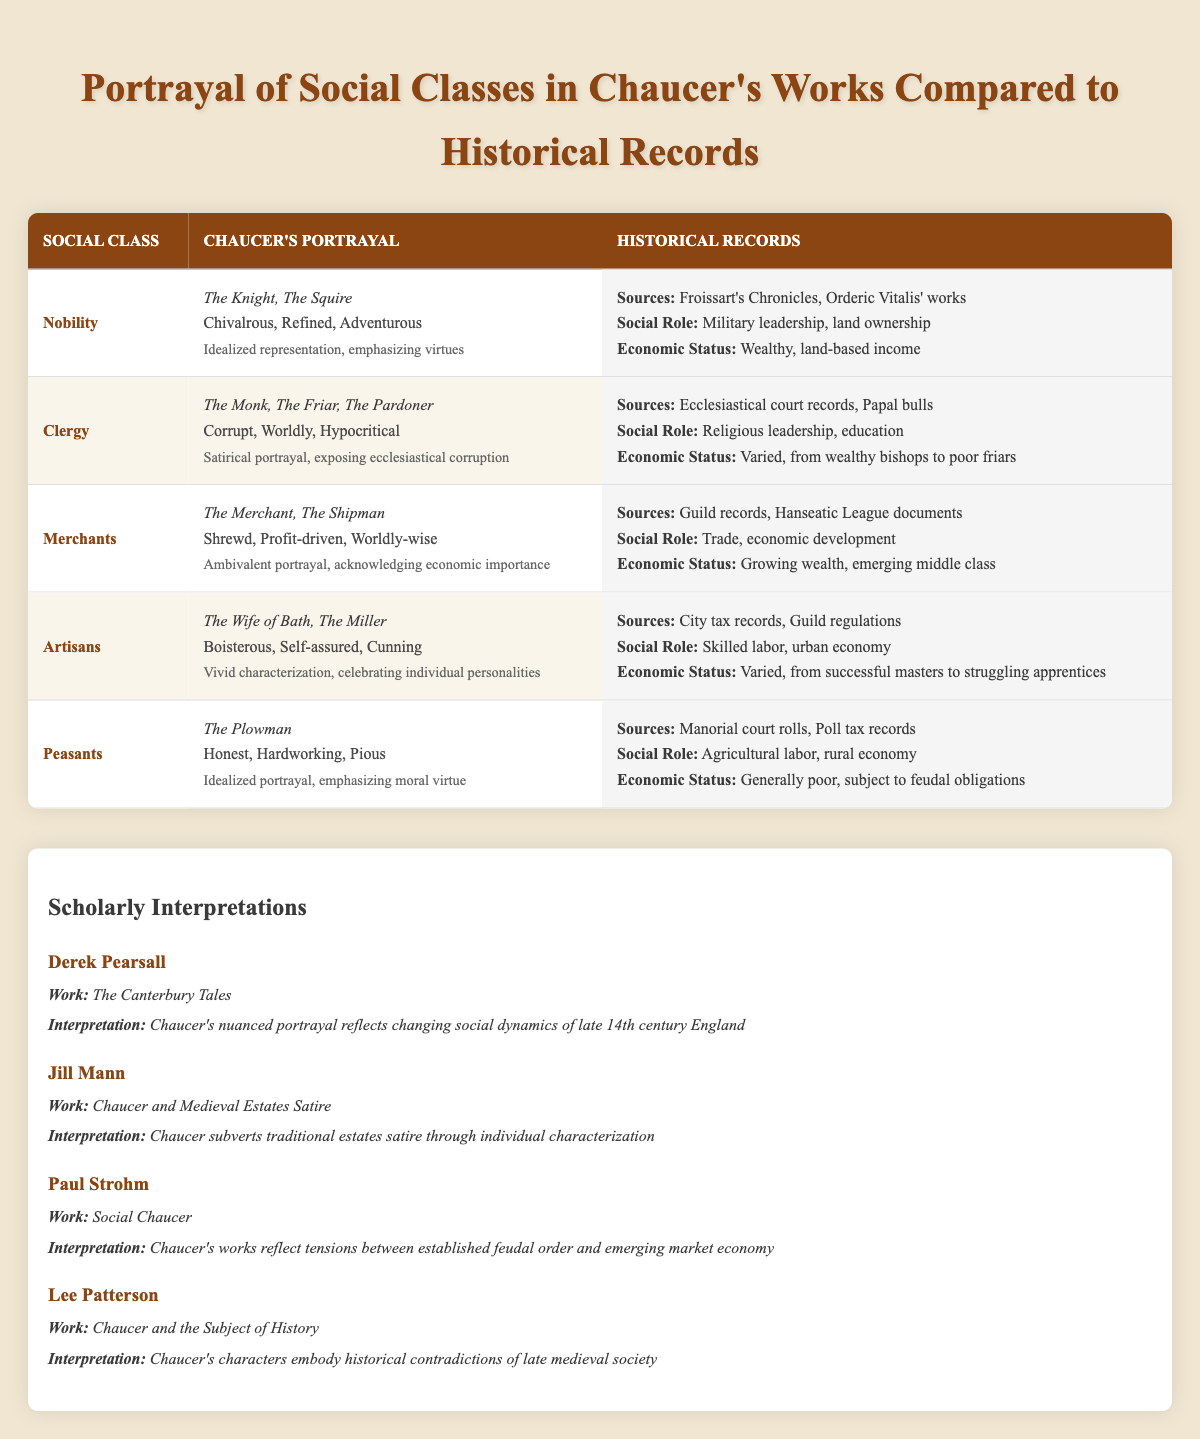What are the traits associated with the Clergy in Chaucer's portrayal? The table lists the traits as "Corrupt, Worldly, Hypocritical" under the "Chaucer's Portrayal" column for the Clergy class.
Answer: Corrupt, Worldly, Hypocritical Who are the characters representing Artisans in Chaucer's works? The table shows "The Wife of Bath" and "The Miller" as characters under the Artisans' portrayal.
Answer: The Wife of Bath, The Miller Is the portrayal of Peasants in Chaucer's works idealized? According to the critique in the table, the portrayal is described as "Idealized portrayal, emphasizing moral virtue" for Peasants.
Answer: Yes Which social class has a critique focusing on exposing corruption? The table indicates that the Clergy's portrayal critiques corruption, specifically stating it's a "Satirical portrayal, exposing ecclesiastical corruption."
Answer: Clergy What sources are cited for the historical records of Merchants? The historical records for Merchants are sourced from "Guild records, Hanseatic League documents," as shown in the Historical Records section of the table.
Answer: Guild records, Hanseatic League documents Compare the economic status of Nobility and Peasants according to historical records. The Nobility is described as "Wealthy, land-based income" while Peasants are noted as "Generally poor, subject to feudal obligations." This indicates a significant difference in economic status.
Answer: Nobility is Wealthy; Peasants are Generally poor How many characters are listed in the portrayal of Nobility and what are their names? The table notes two characters—the Knight and the Squire—as part of Nobility's portrayal. This is a straightforward count of the characters listed under Nobility.
Answer: There are 2 characters: The Knight, The Squire What is the social role of Merchants as per historical records? The table lists the social role for Merchants as "Trade, economic development," drawing a connection to their role in society.
Answer: Trade, economic development Which trait is not associated with Peasants in Chaucer's portrayals? The traits for Peasants are "Honest, Hardworking, Pious." Thus, any other trait not listed in this set would be excluded. So, traits like "Worldly" or "Cunning" would not be associated.
Answer: Worldly, Cunning 